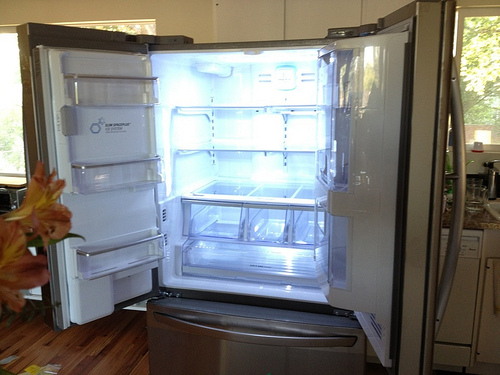Please provide the bounding box coordinate of the region this sentence describes: silver cannister on countertop. The coordinates [0.87, 0.38, 0.96, 0.48] would accurately frame the silver canister situated just at the edge of the right-hand countertop. 